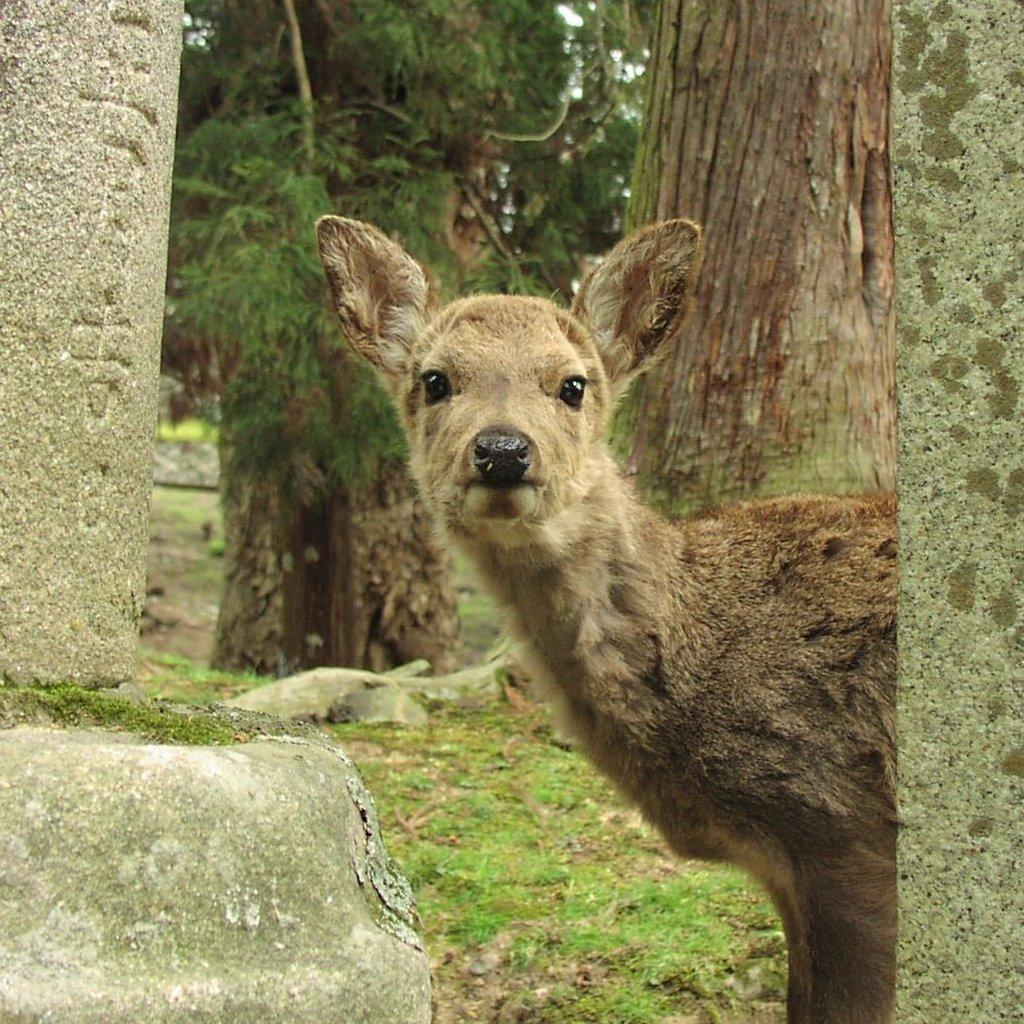What type of creature can be seen in the image? There is an animal in the image. What is the animal's position in relation to the ground? The animal is standing on the ground. What type of vegetation is present in the image? Grass is present in the image. What can be seen in the background of the image? There are trees in the background of the image. What type of company is located near the cemetery in the image? There is no company or cemetery present in the image; it features an animal standing on the ground with grass and trees in the background. 